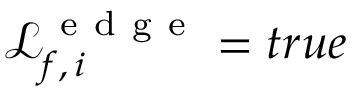Convert formula to latex. <formula><loc_0><loc_0><loc_500><loc_500>\mathcal { L } _ { f , \, i } ^ { e d g e } = t r u e</formula> 